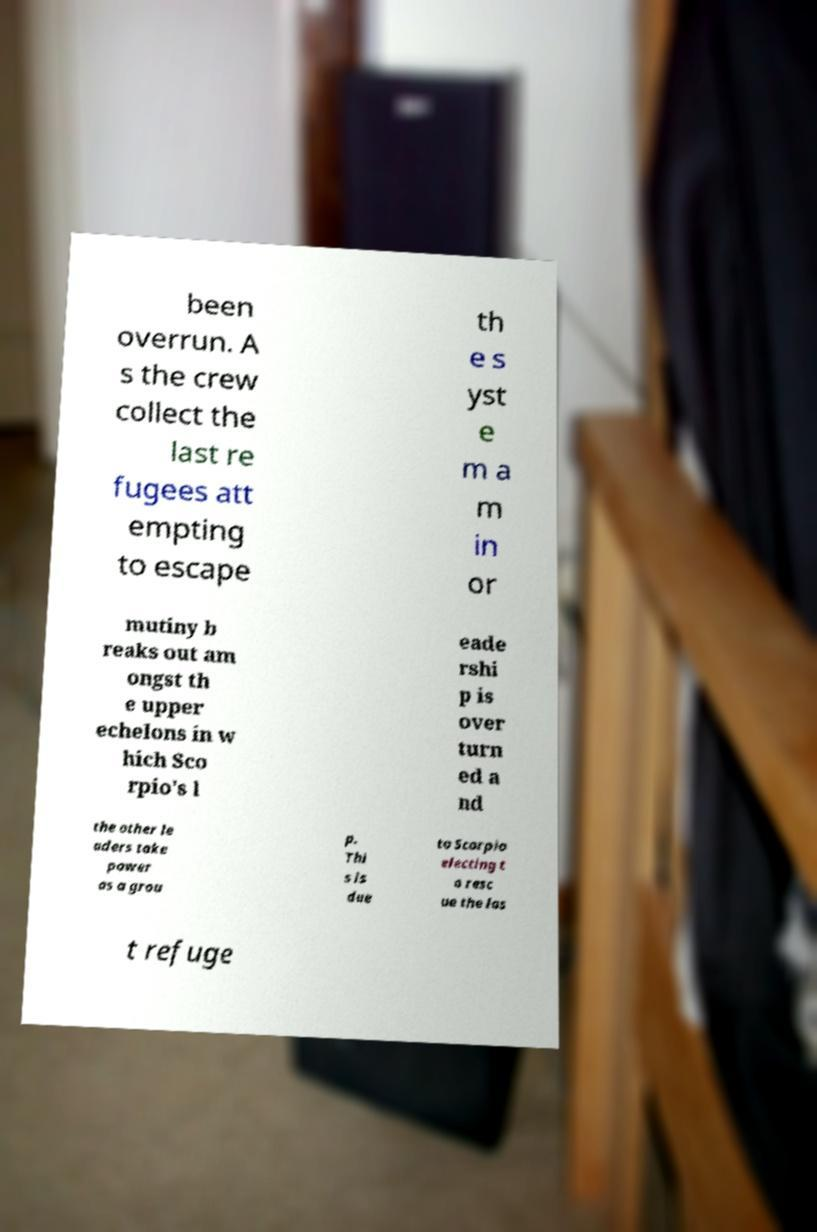Please identify and transcribe the text found in this image. been overrun. A s the crew collect the last re fugees att empting to escape th e s yst e m a m in or mutiny b reaks out am ongst th e upper echelons in w hich Sco rpio's l eade rshi p is over turn ed a nd the other le aders take power as a grou p. Thi s is due to Scorpio electing t o resc ue the las t refuge 